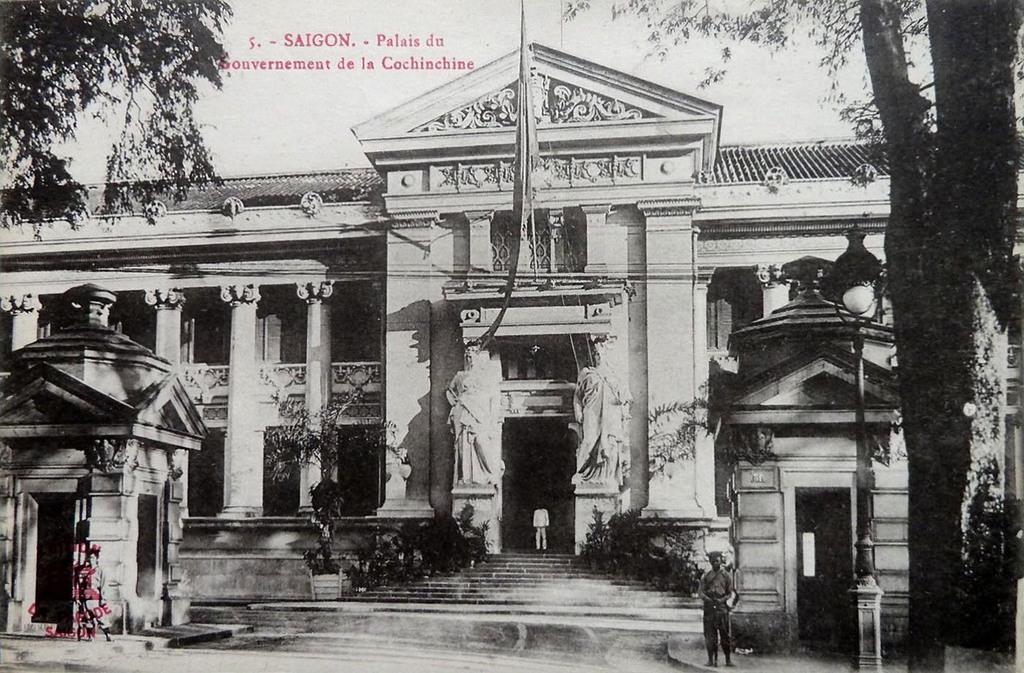How would you summarize this image in a sentence or two? This is a black and white image. In this image we can see a building. There are people. At the bottom of the image there is road. At the top of the image there is text. To the right side of the image there is a tree. 